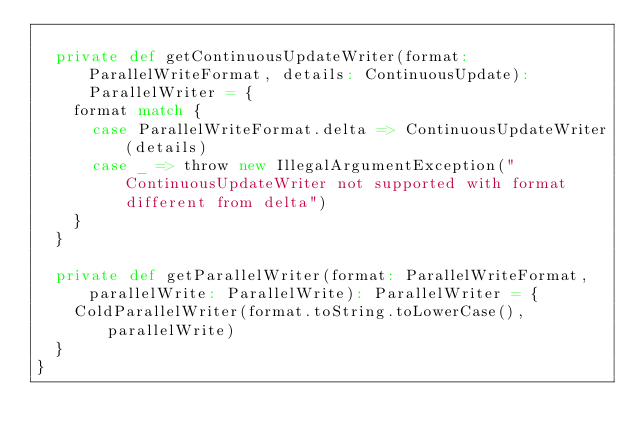Convert code to text. <code><loc_0><loc_0><loc_500><loc_500><_Scala_>
  private def getContinuousUpdateWriter(format: ParallelWriteFormat, details: ContinuousUpdate): ParallelWriter = {
    format match {
      case ParallelWriteFormat.delta => ContinuousUpdateWriter(details)
      case _ => throw new IllegalArgumentException("ContinuousUpdateWriter not supported with format different from delta")
    }
  }

  private def getParallelWriter(format: ParallelWriteFormat, parallelWrite: ParallelWrite): ParallelWriter = {
    ColdParallelWriter(format.toString.toLowerCase(), parallelWrite)
  }
}
</code> 